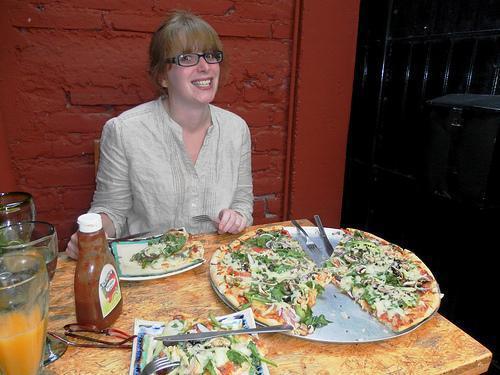How many people are in the photo?
Give a very brief answer. 1. 